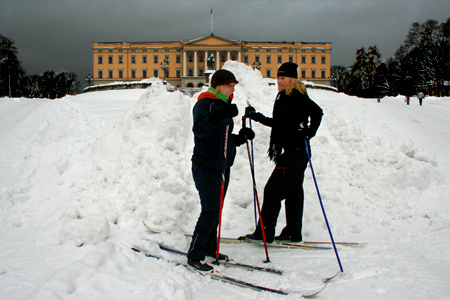Describe the scene if it was taking place in an alternate universe. In an alternate universe, this scene might feature fantastically colored snow, glowing softly under a luminous sky of swirling pastel hues. The building in the background could be a fantastical castle made of crystalline structures that shimmer in the seemingly magical light. The two individuals might be otherworldly beings with feature distinct attire—one wearing a silver suit adorned with intricate, glowing patterns and the other in flowing robes that change colors with each step. They could be discussing a quest to find rare, enchanted objects scattered across this mystical winter realm. 